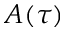<formula> <loc_0><loc_0><loc_500><loc_500>A ( \tau )</formula> 